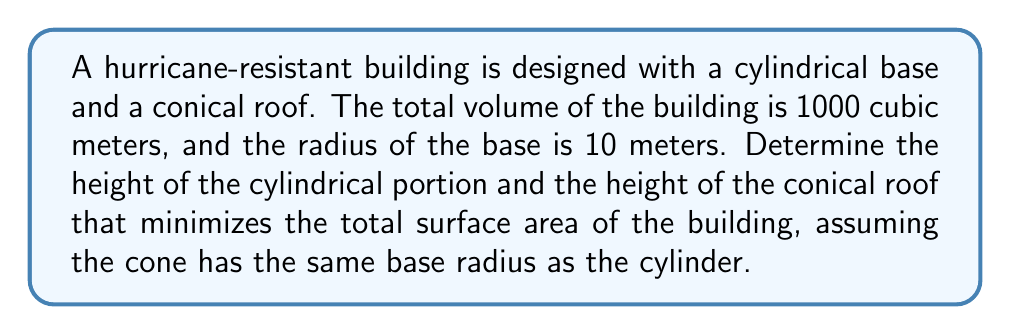Give your solution to this math problem. Let's approach this step-by-step:

1) Let $h$ be the height of the cylindrical portion and $H$ be the height of the conical roof.

2) The volume of the building is the sum of the volumes of the cylinder and the cone:

   $$V = \pi r^2 h + \frac{1}{3}\pi r^2 H = 1000$$

   Where $r = 10$ (given radius).

3) Substituting the known values:

   $$1000 \pi + \frac{1}{3}\pi 100 H = 1000$$

4) Solving for $H$:

   $$H = \frac{3000 - 1000\pi}{100\pi} \approx 3.18$$

5) The surface area $S$ of the building is the sum of the lateral surface area of the cylinder, the area of the circular base, and the lateral surface area of the cone:

   $$S = 2\pi rh + \pi r^2 + \pi r\sqrt{r^2 + H^2}$$

6) Substituting $h = \frac{1000 - \frac{1}{3}\pi r^2 H}{\pi r^2}$ from step 2:

   $$S = 2000 - \frac{200}{3}H + 100\pi + 10\pi\sqrt{100 + H^2}$$

7) To minimize $S$, we differentiate with respect to $H$ and set to zero:

   $$\frac{dS}{dH} = -\frac{200}{3} + \frac{10\pi H}{\sqrt{100 + H^2}} = 0$$

8) Solving this equation numerically (as it's not easily solvable algebraically), we get:

   $$H \approx 5.77$$

9) From this, we can calculate $h$:

   $$h = \frac{1000 - \frac{1}{3}\pi 100 (5.77)}{\pi 100} \approx 7.41$$

Therefore, the optimal heights are approximately 7.41 meters for the cylindrical portion and 5.77 meters for the conical roof.
Answer: Cylinder height: 7.41 m, Cone height: 5.77 m 